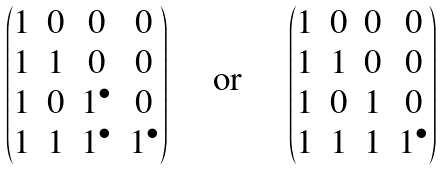<formula> <loc_0><loc_0><loc_500><loc_500>\begin{pmatrix} 1 & 0 & 0 & 0 \\ 1 & 1 & 0 & 0 \\ 1 & 0 & 1 ^ { \bullet } & 0 \\ 1 & 1 & 1 ^ { \bullet } & 1 ^ { \bullet } \end{pmatrix} \quad \text { or } \quad \begin{pmatrix} 1 & 0 & 0 & 0 \\ 1 & 1 & 0 & 0 \\ 1 & 0 & 1 & 0 \\ 1 & 1 & 1 & 1 ^ { \bullet } \end{pmatrix}</formula> 